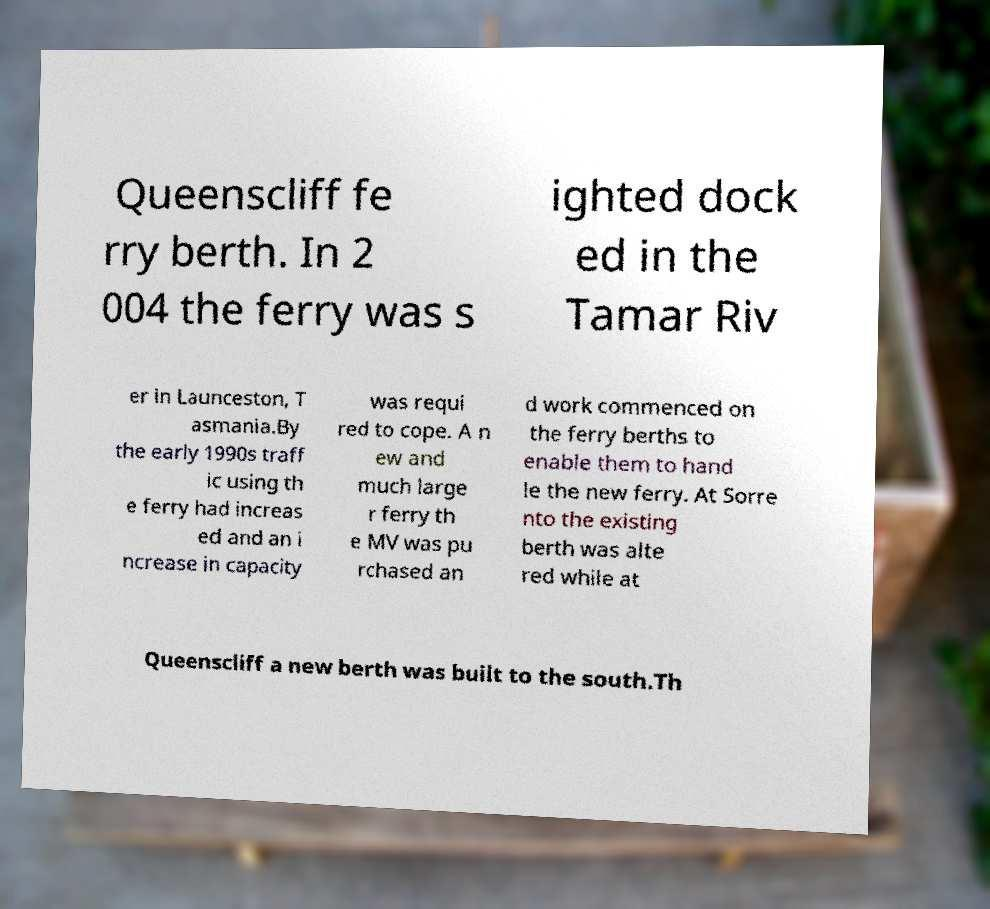Could you assist in decoding the text presented in this image and type it out clearly? Queenscliff fe rry berth. In 2 004 the ferry was s ighted dock ed in the Tamar Riv er in Launceston, T asmania.By the early 1990s traff ic using th e ferry had increas ed and an i ncrease in capacity was requi red to cope. A n ew and much large r ferry th e MV was pu rchased an d work commenced on the ferry berths to enable them to hand le the new ferry. At Sorre nto the existing berth was alte red while at Queenscliff a new berth was built to the south.Th 